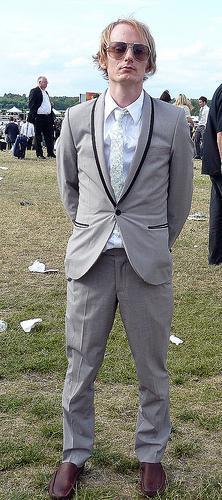How many suitcases are shown?
Give a very brief answer. 1. 